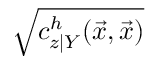Convert formula to latex. <formula><loc_0><loc_0><loc_500><loc_500>\sqrt { c _ { z | Y } ^ { h } ( \vec { x } , \vec { x } ) }</formula> 